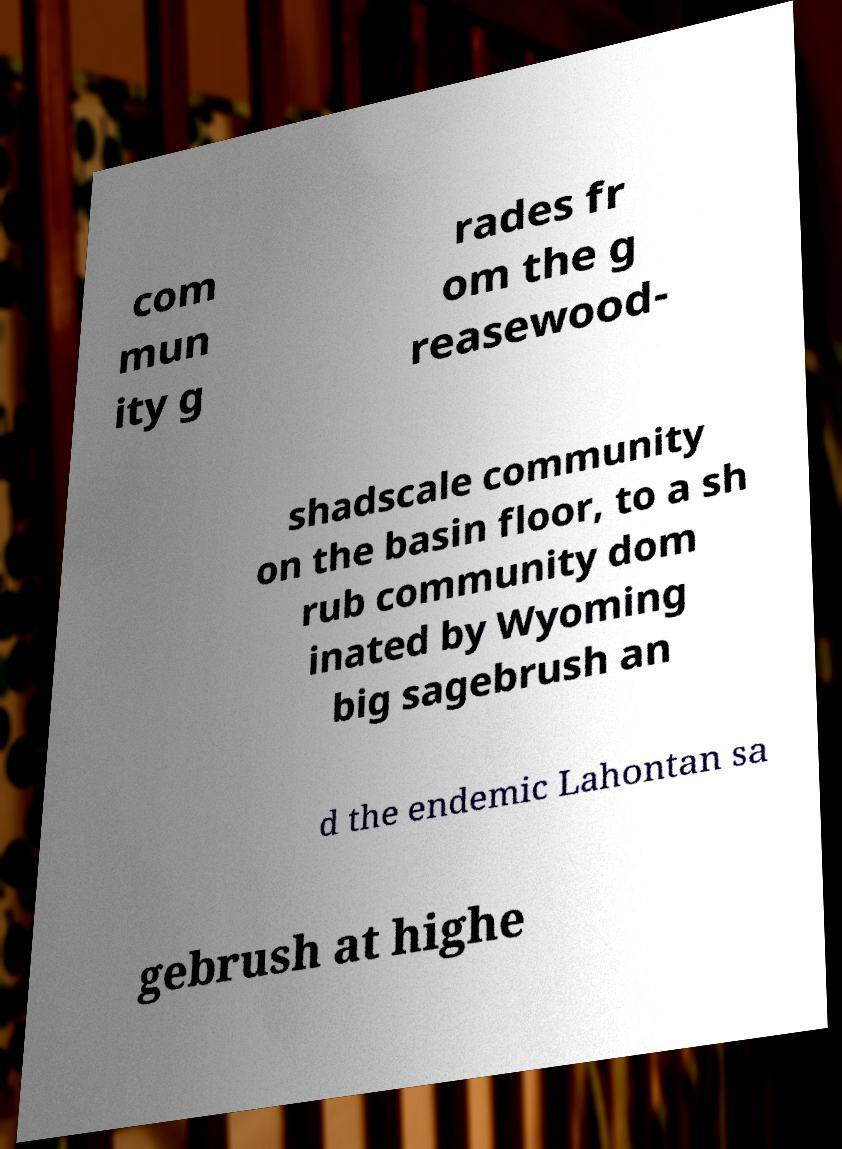There's text embedded in this image that I need extracted. Can you transcribe it verbatim? com mun ity g rades fr om the g reasewood- shadscale community on the basin floor, to a sh rub community dom inated by Wyoming big sagebrush an d the endemic Lahontan sa gebrush at highe 